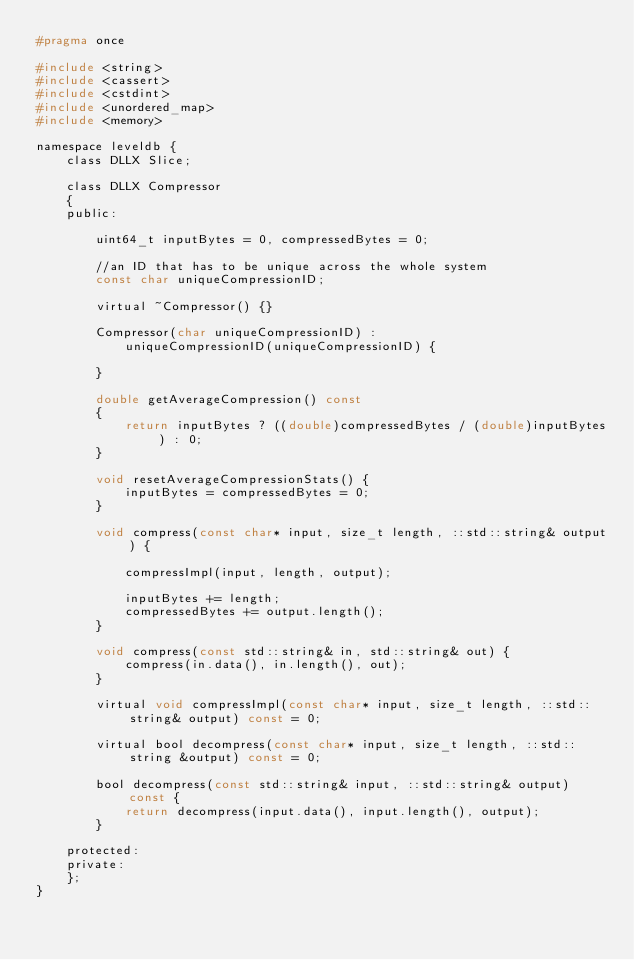<code> <loc_0><loc_0><loc_500><loc_500><_C_>#pragma once

#include <string>
#include <cassert>
#include <cstdint>
#include <unordered_map>
#include <memory>

namespace leveldb {
	class DLLX Slice;

	class DLLX Compressor
	{
	public:

		uint64_t inputBytes = 0, compressedBytes = 0;
 
		//an ID that has to be unique across the whole system
		const char uniqueCompressionID;

        virtual ~Compressor() {}
        
		Compressor(char uniqueCompressionID) :
			uniqueCompressionID(uniqueCompressionID) {

		}

		double getAverageCompression() const
		{
			return inputBytes ? ((double)compressedBytes / (double)inputBytes) : 0;
		}

		void resetAverageCompressionStats() {
			inputBytes = compressedBytes = 0;
		}

		void compress(const char* input, size_t length, ::std::string& output) {

			compressImpl(input, length, output);

			inputBytes += length;
			compressedBytes += output.length();
		}

		void compress(const std::string& in, std::string& out) {
			compress(in.data(), in.length(), out);
		}

		virtual void compressImpl(const char* input, size_t length, ::std::string& output) const = 0;

		virtual bool decompress(const char* input, size_t length, ::std::string &output) const = 0;

		bool decompress(const std::string& input, ::std::string& output) const {
			return decompress(input.data(), input.length(), output);
		}

	protected:
	private:
	};
}</code> 